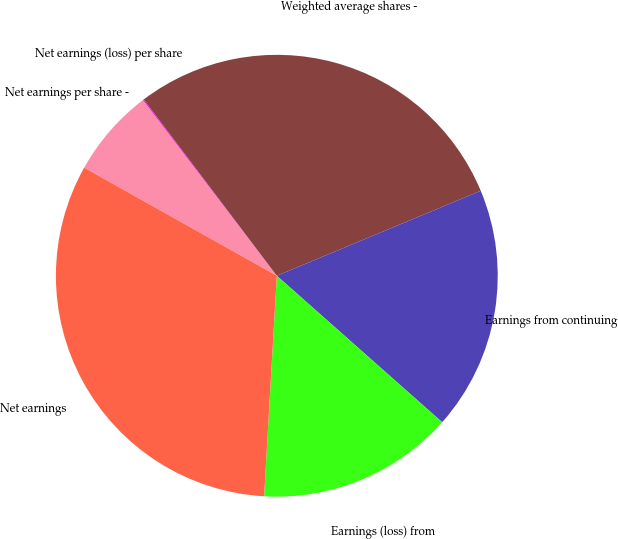Convert chart to OTSL. <chart><loc_0><loc_0><loc_500><loc_500><pie_chart><fcel>Net earnings per share -<fcel>Net earnings (loss) per share<fcel>Weighted average shares -<fcel>Earnings from continuing<fcel>Earnings (loss) from<fcel>Net earnings<nl><fcel>6.5%<fcel>0.07%<fcel>29.01%<fcel>17.82%<fcel>14.38%<fcel>32.22%<nl></chart> 